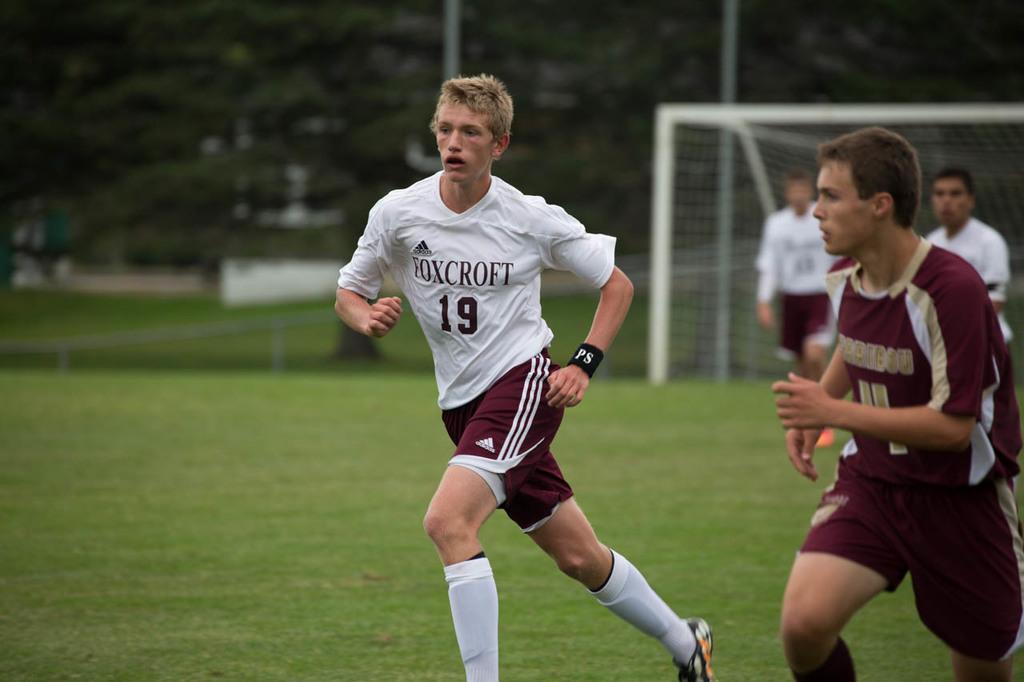Describe this image in one or two sentences. There are two people running and we can see grass. In the background we can see people,net,poles and trees. 